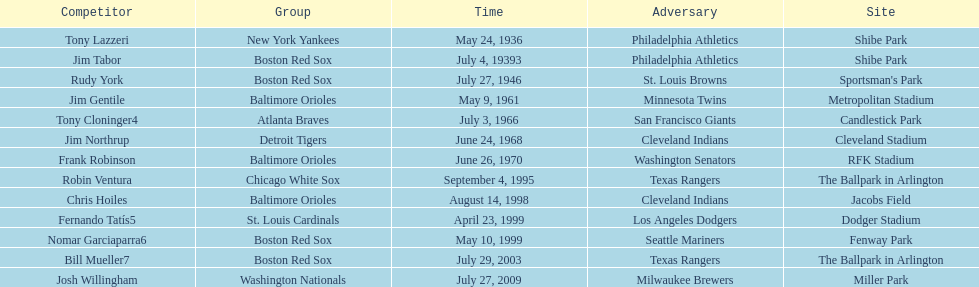Help me parse the entirety of this table. {'header': ['Competitor', 'Group', 'Time', 'Adversary', 'Site'], 'rows': [['Tony Lazzeri', 'New York Yankees', 'May 24, 1936', 'Philadelphia Athletics', 'Shibe Park'], ['Jim Tabor', 'Boston Red Sox', 'July 4, 19393', 'Philadelphia Athletics', 'Shibe Park'], ['Rudy York', 'Boston Red Sox', 'July 27, 1946', 'St. Louis Browns', "Sportsman's Park"], ['Jim Gentile', 'Baltimore Orioles', 'May 9, 1961', 'Minnesota Twins', 'Metropolitan Stadium'], ['Tony Cloninger4', 'Atlanta Braves', 'July 3, 1966', 'San Francisco Giants', 'Candlestick Park'], ['Jim Northrup', 'Detroit Tigers', 'June 24, 1968', 'Cleveland Indians', 'Cleveland Stadium'], ['Frank Robinson', 'Baltimore Orioles', 'June 26, 1970', 'Washington Senators', 'RFK Stadium'], ['Robin Ventura', 'Chicago White Sox', 'September 4, 1995', 'Texas Rangers', 'The Ballpark in Arlington'], ['Chris Hoiles', 'Baltimore Orioles', 'August 14, 1998', 'Cleveland Indians', 'Jacobs Field'], ['Fernando Tatís5', 'St. Louis Cardinals', 'April 23, 1999', 'Los Angeles Dodgers', 'Dodger Stadium'], ['Nomar Garciaparra6', 'Boston Red Sox', 'May 10, 1999', 'Seattle Mariners', 'Fenway Park'], ['Bill Mueller7', 'Boston Red Sox', 'July 29, 2003', 'Texas Rangers', 'The Ballpark in Arlington'], ['Josh Willingham', 'Washington Nationals', 'July 27, 2009', 'Milwaukee Brewers', 'Miller Park']]} What was the name of the last person to accomplish this up to date? Josh Willingham. 